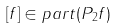Convert formula to latex. <formula><loc_0><loc_0><loc_500><loc_500>[ f ] \in p a r t ( P _ { 2 } f )</formula> 